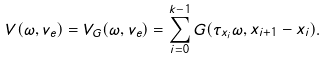<formula> <loc_0><loc_0><loc_500><loc_500>V ( \omega , v _ { e } ) = V _ { G } ( \omega , v _ { e } ) = \sum _ { i = 0 } ^ { k - 1 } G ( \tau _ { x _ { i } } \omega , x _ { i + 1 } - x _ { i } ) .</formula> 